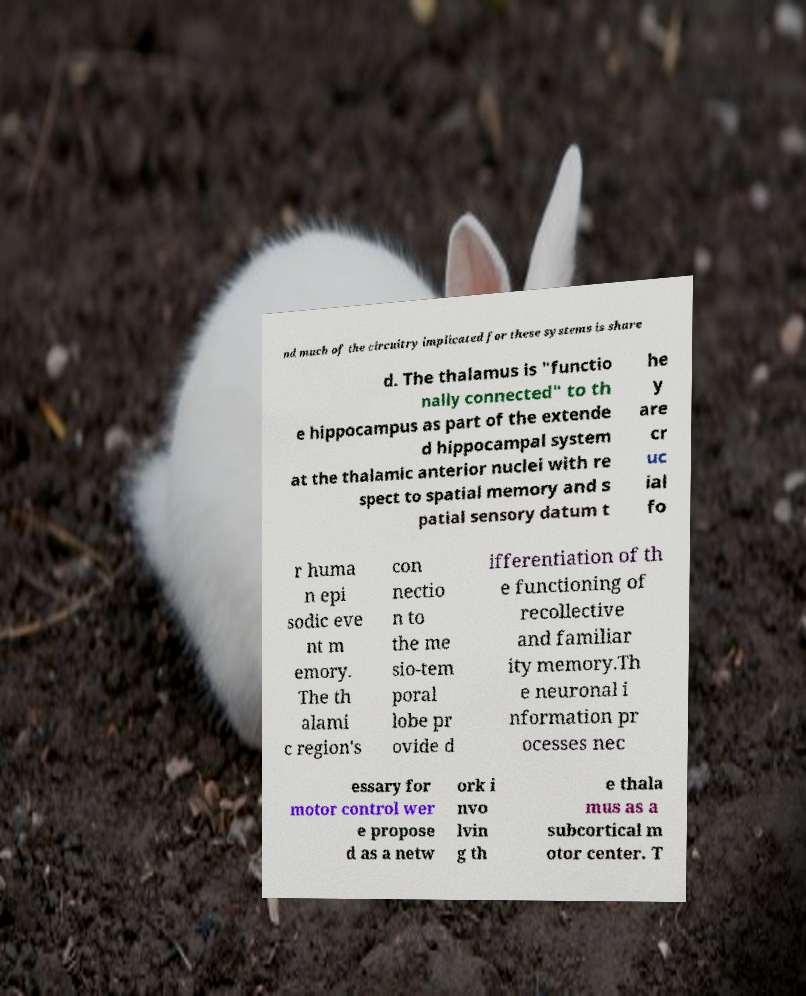Please read and relay the text visible in this image. What does it say? nd much of the circuitry implicated for these systems is share d. The thalamus is "functio nally connected" to th e hippocampus as part of the extende d hippocampal system at the thalamic anterior nuclei with re spect to spatial memory and s patial sensory datum t he y are cr uc ial fo r huma n epi sodic eve nt m emory. The th alami c region's con nectio n to the me sio-tem poral lobe pr ovide d ifferentiation of th e functioning of recollective and familiar ity memory.Th e neuronal i nformation pr ocesses nec essary for motor control wer e propose d as a netw ork i nvo lvin g th e thala mus as a subcortical m otor center. T 